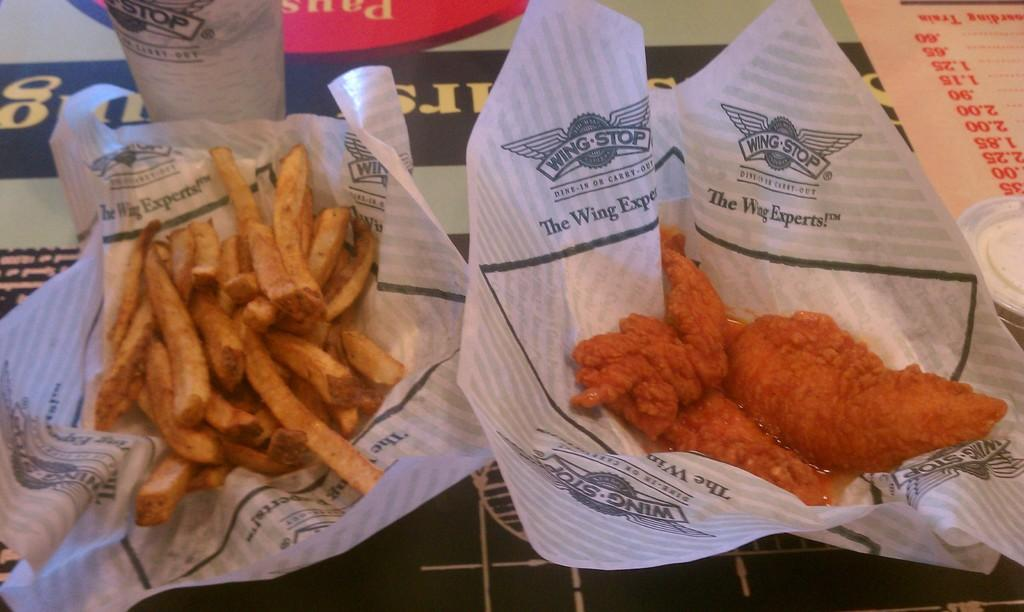What type of items can be seen in the image? There are eatable items in the image. How are the eatable items arranged or contained in the image? The eatable items are placed in a packet. How many lumber pieces can be seen in the image? There are no lumber pieces present in the image. What type of cup is being used to serve the eatable items in the image? There is no cup present in the image; the eatable items are placed in a packet. 